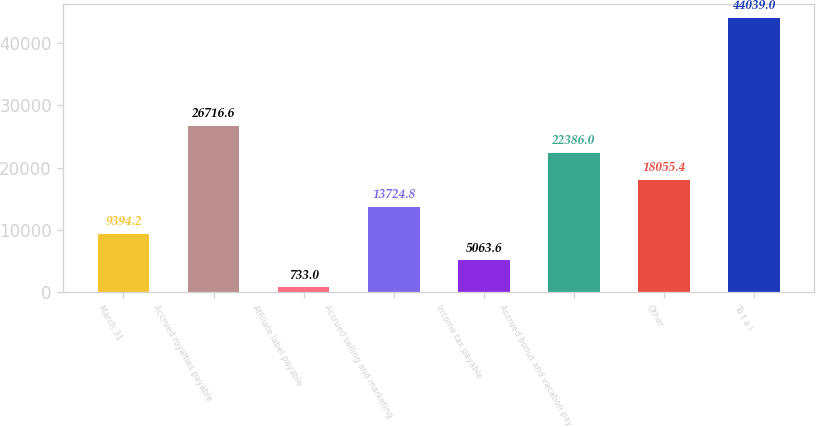<chart> <loc_0><loc_0><loc_500><loc_500><bar_chart><fcel>March 31<fcel>Accrued royalties payable<fcel>Affiliate label payable<fcel>Accrued selling and marketing<fcel>Income tax payable<fcel>Accrued bonus and vacation pay<fcel>Other<fcel>To t a l<nl><fcel>9394.2<fcel>26716.6<fcel>733<fcel>13724.8<fcel>5063.6<fcel>22386<fcel>18055.4<fcel>44039<nl></chart> 